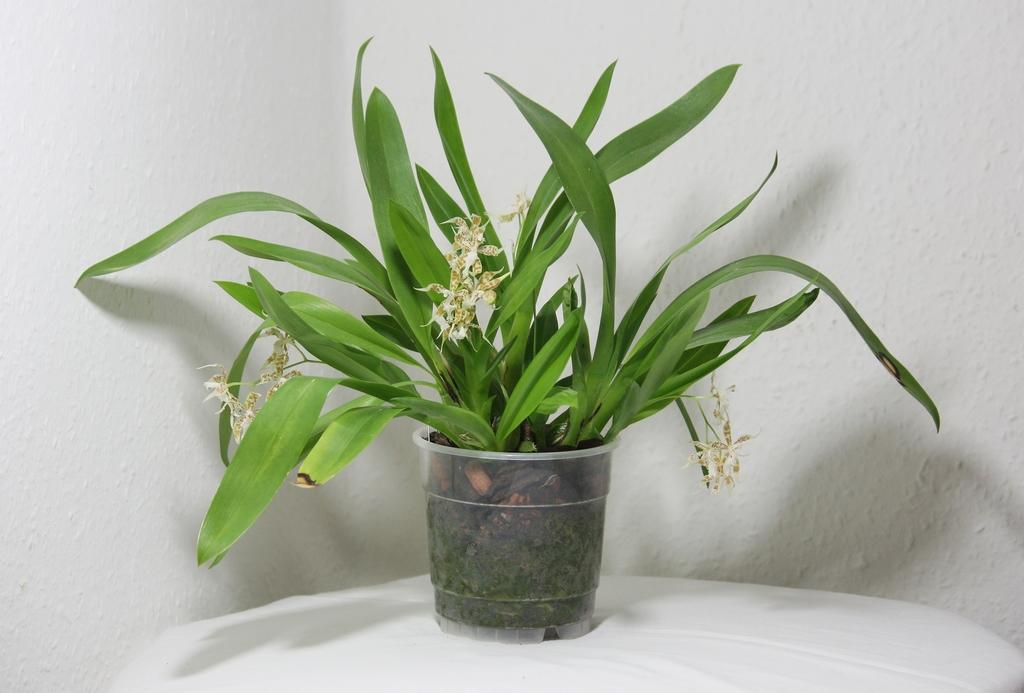What object is the main focus of the image? There is a flower pot in the image. Where is the flower pot located? The flower pot is on a white table. What can be seen in the background of the image? There is a wall visible in the background of the image. What type of skate is being used to water the plants in the flower pot? There is no skate present in the image, and the plants in the flower pot are not being watered. 